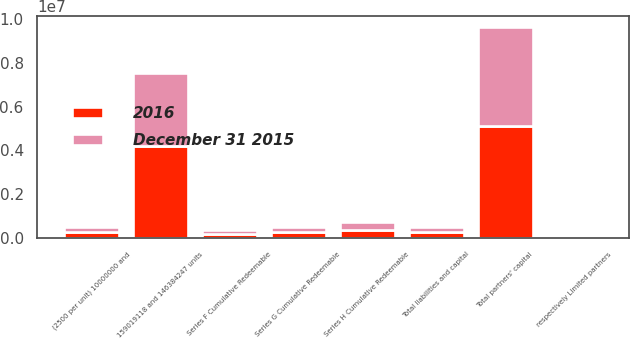Convert chart to OTSL. <chart><loc_0><loc_0><loc_500><loc_500><stacked_bar_chart><ecel><fcel>Series F Cumulative Redeemable<fcel>Series G Cumulative Redeemable<fcel>Series H Cumulative Redeemable<fcel>(2500 per unit) 10000000 and<fcel>159019118 and 146384247 units<fcel>respectively Limited partners<fcel>Total partners' capital<fcel>Total liabilities and capital<nl><fcel>2016<fcel>176191<fcel>241468<fcel>353290<fcel>242012<fcel>4.21866e+06<fcel>34698<fcel>5.1257e+06<fcel>242013<nl><fcel>December 31 2015<fcel>176191<fcel>241468<fcel>353290<fcel>242014<fcel>3.30522e+06<fcel>33986<fcel>4.52838e+06<fcel>242013<nl></chart> 